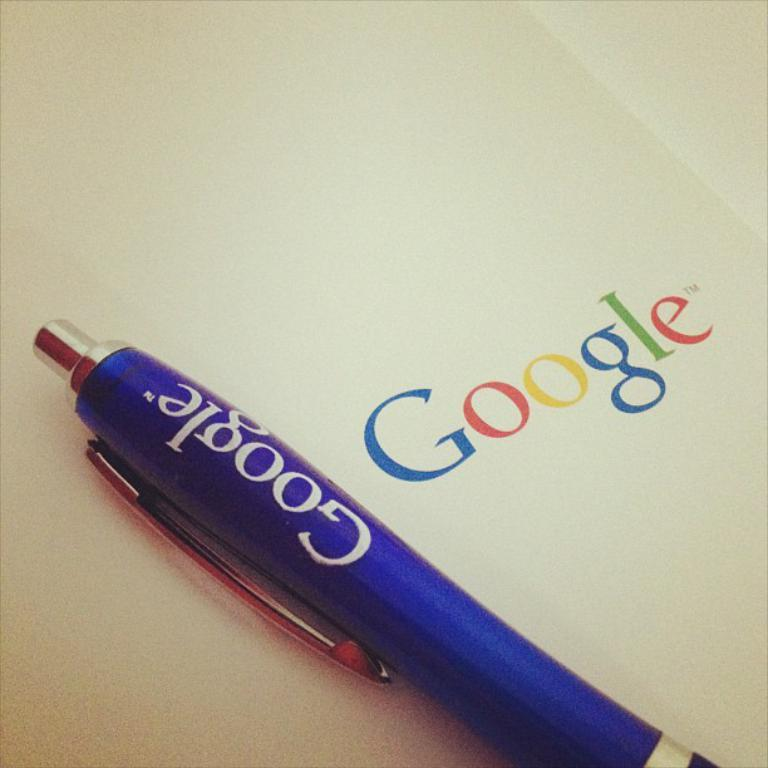What type of writing instrument is visible in the image? There is a blue pen in the image. Where is the pen located in the image? The pen is on a surface in the image. What can be seen on the pen? There is writing on the pen. What else is written in the image? There is writing on the surface. What type of land can be seen in the image? There is no land visible in the image; it features a blue pen on a surface with writing. What type of work is being done in the image? There is no indication of work being done in the image; it shows a pen and writing on a surface. 